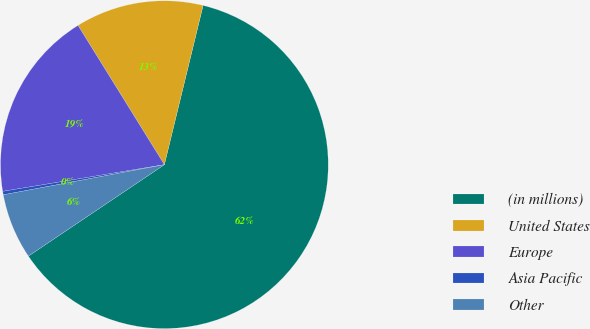Convert chart to OTSL. <chart><loc_0><loc_0><loc_500><loc_500><pie_chart><fcel>(in millions)<fcel>United States<fcel>Europe<fcel>Asia Pacific<fcel>Other<nl><fcel>61.78%<fcel>12.63%<fcel>18.77%<fcel>0.34%<fcel>6.48%<nl></chart> 